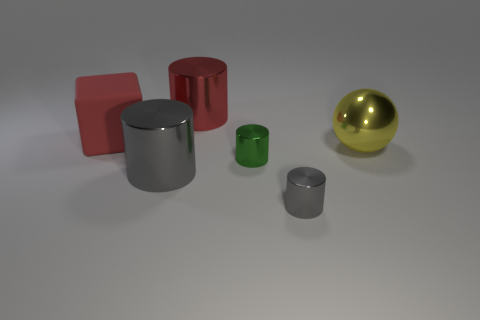Based on the shadows and lighting, where do you think the light source is coming from in this scene? The shadows cast by the objects are fairly soft and extend toward the lower right of the image. This suggests that the light source is located above and to the left side of the scene, likely out of view of the image. It's diffused light, indicating it might be an overcast day or a soft light in a studio setting. 